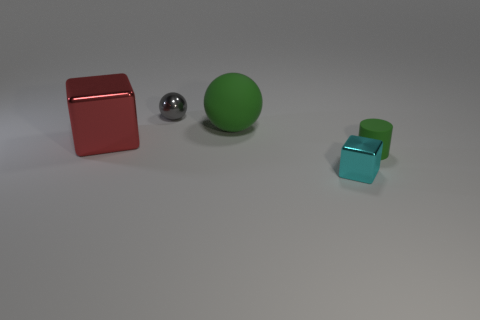Is the color of the cylinder the same as the big rubber object?
Ensure brevity in your answer.  Yes. How many balls are either tiny purple metal things or small green rubber things?
Make the answer very short. 0. Are there an equal number of green objects in front of the large red metal thing and gray balls that are behind the metal sphere?
Ensure brevity in your answer.  No. How many gray things are behind the metal thing that is right of the large object behind the large red object?
Your answer should be compact. 1. What is the shape of the big thing that is the same color as the small matte cylinder?
Offer a very short reply. Sphere. There is a small matte cylinder; does it have the same color as the sphere to the right of the small gray sphere?
Your answer should be compact. Yes. Are there more objects that are in front of the small green thing than big matte blocks?
Provide a short and direct response. Yes. How many objects are either metal objects that are on the left side of the tiny block or shiny things to the right of the small gray metallic thing?
Offer a very short reply. 3. What is the size of the other cube that is the same material as the small cyan block?
Your response must be concise. Large. There is a green object that is to the left of the cyan thing; does it have the same shape as the tiny gray object?
Make the answer very short. Yes. 